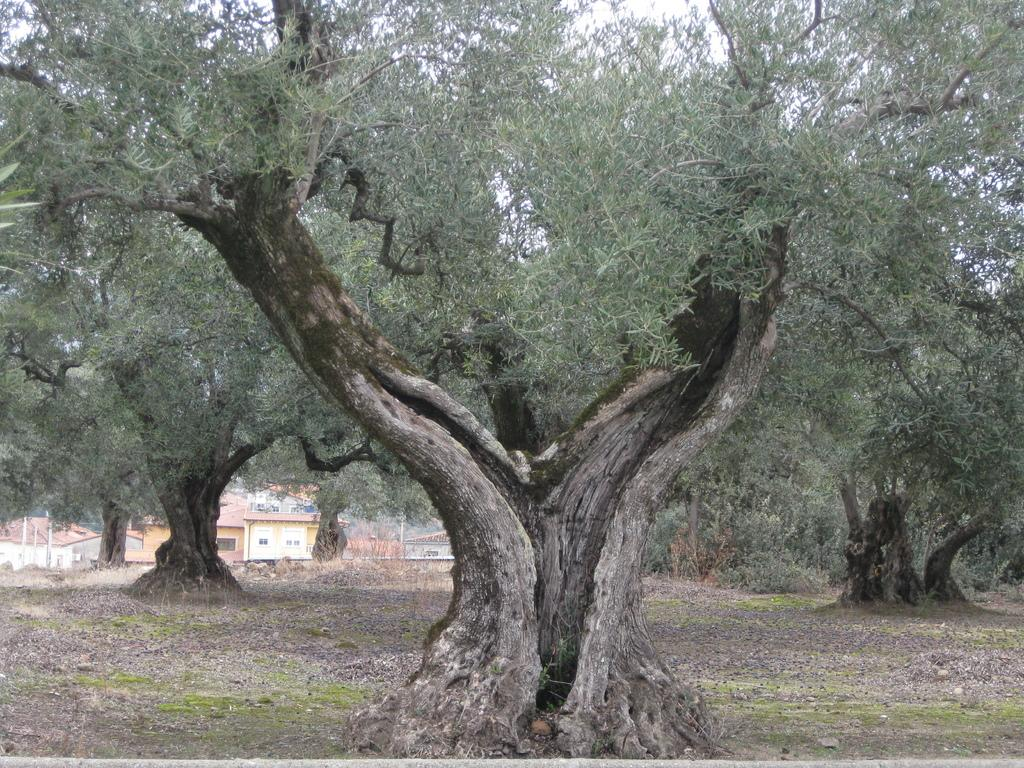What is located in the center of the image? There are trees, buildings, and poles in the center of the image. What can be seen at the bottom of the image? The ground is visible at the bottom of the image. What is visible at the top of the image? The sky is visible at the top of the image. What type of muscle can be seen flexing in the image? There is no muscle present in the image; it features trees, buildings, poles, ground, and sky. What kind of cup is being used by the person in the image? There is no person or cup present in the image. 